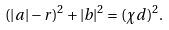Convert formula to latex. <formula><loc_0><loc_0><loc_500><loc_500>( | a | - r ) ^ { 2 } + | b | ^ { 2 } = ( \chi d ) ^ { 2 } .</formula> 